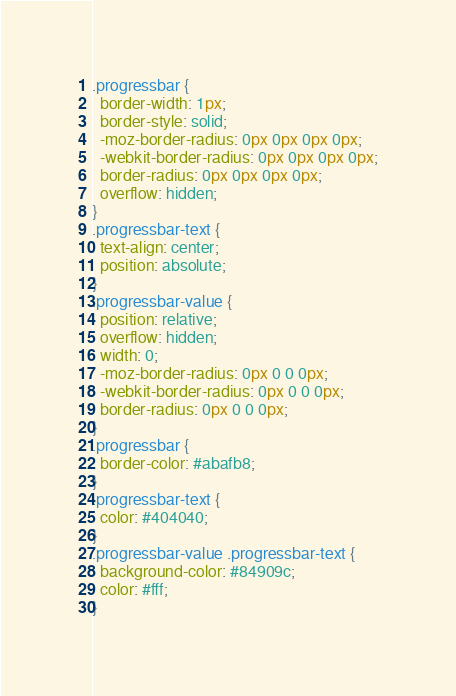<code> <loc_0><loc_0><loc_500><loc_500><_CSS_>.progressbar {
  border-width: 1px;
  border-style: solid;
  -moz-border-radius: 0px 0px 0px 0px;
  -webkit-border-radius: 0px 0px 0px 0px;
  border-radius: 0px 0px 0px 0px;
  overflow: hidden;
}
.progressbar-text {
  text-align: center;
  position: absolute;
}
.progressbar-value {
  position: relative;
  overflow: hidden;
  width: 0;
  -moz-border-radius: 0px 0 0 0px;
  -webkit-border-radius: 0px 0 0 0px;
  border-radius: 0px 0 0 0px;
}
.progressbar {
  border-color: #abafb8;
}
.progressbar-text {
  color: #404040;
}
.progressbar-value .progressbar-text {
  background-color: #84909c;
  color: #fff;
}
</code> 